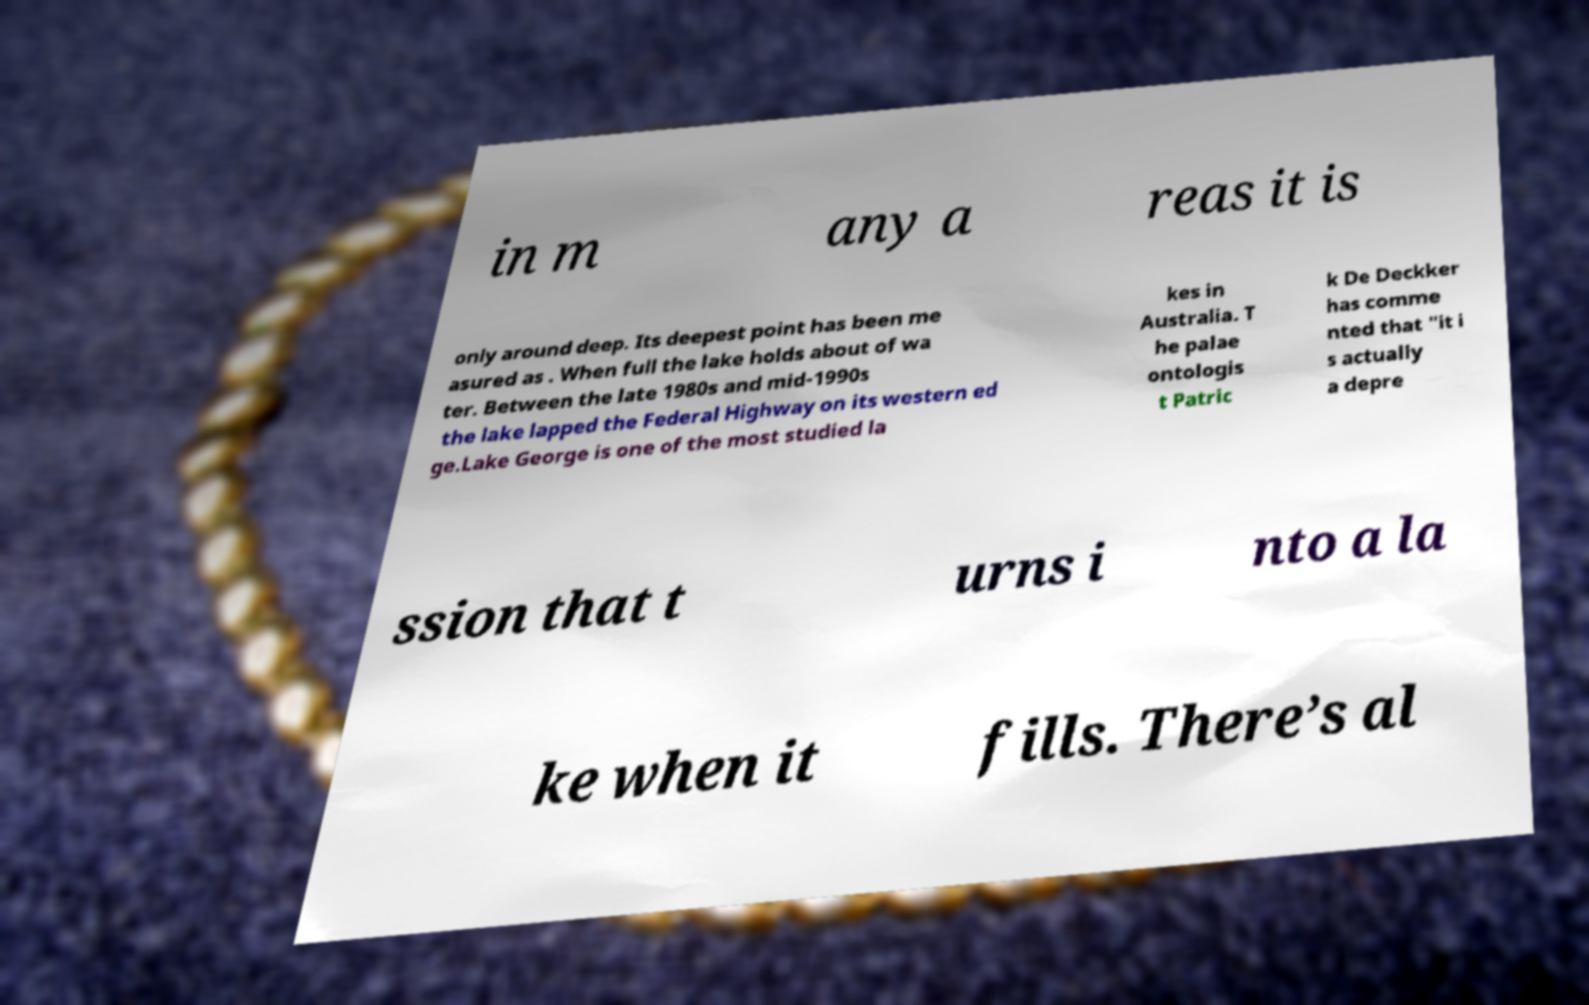Can you read and provide the text displayed in the image?This photo seems to have some interesting text. Can you extract and type it out for me? in m any a reas it is only around deep. Its deepest point has been me asured as . When full the lake holds about of wa ter. Between the late 1980s and mid-1990s the lake lapped the Federal Highway on its western ed ge.Lake George is one of the most studied la kes in Australia. T he palae ontologis t Patric k De Deckker has comme nted that "it i s actually a depre ssion that t urns i nto a la ke when it fills. There’s al 